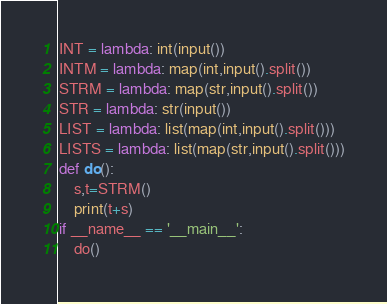<code> <loc_0><loc_0><loc_500><loc_500><_Python_>INT = lambda: int(input())
INTM = lambda: map(int,input().split())
STRM = lambda: map(str,input().split())
STR = lambda: str(input())
LIST = lambda: list(map(int,input().split()))
LISTS = lambda: list(map(str,input().split()))
def do():
    s,t=STRM()
    print(t+s)
if __name__ == '__main__':
    do()</code> 